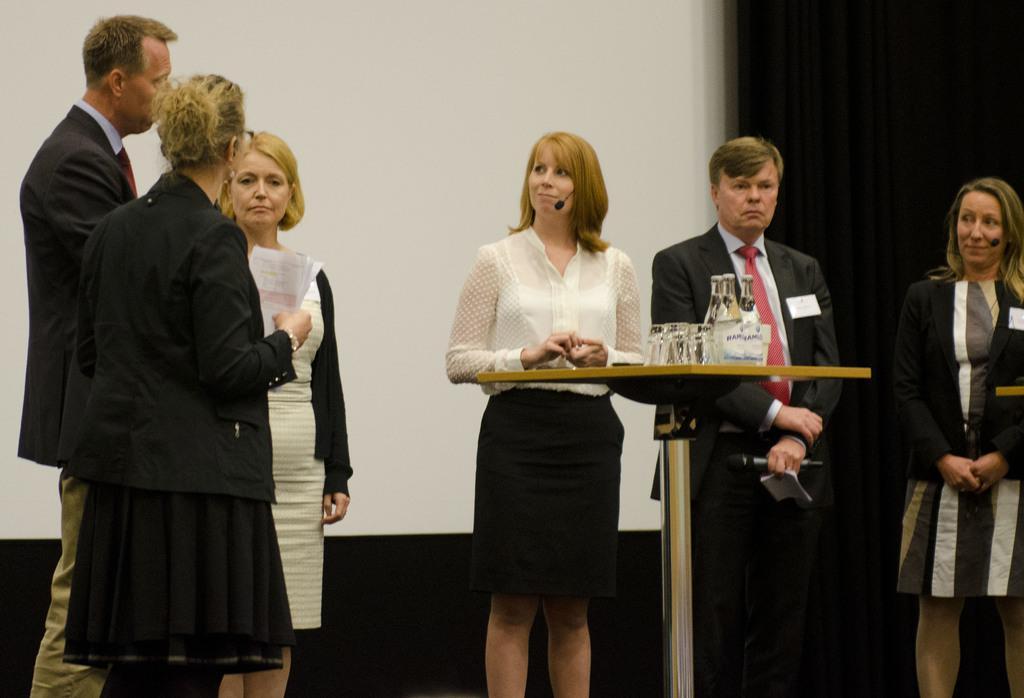How would you summarize this image in a sentence or two? In this picture I can see few people standing, On the left i can see a woman holding papers in the hands and I can see a table with few bottles and glasses on it on the back and I can see a projector screen. 